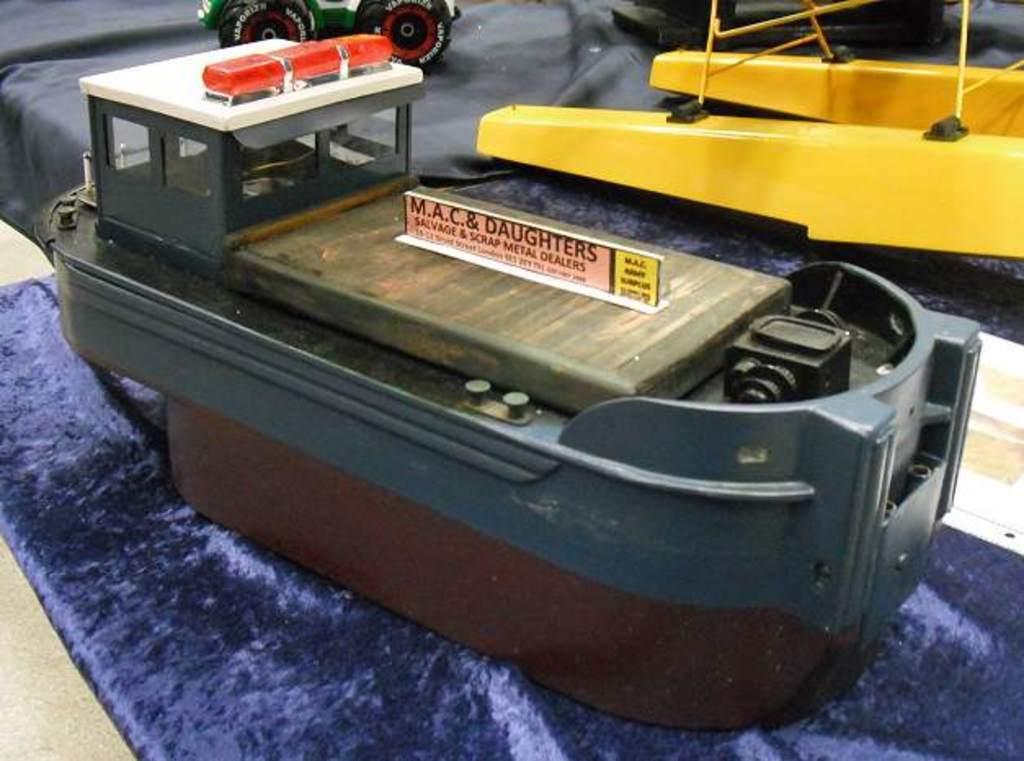In one or two sentences, can you explain what this image depicts? In this image we can see some toys on the surface, there is a board with some text written on it, also we can see papers, and a blue colored cloth. 